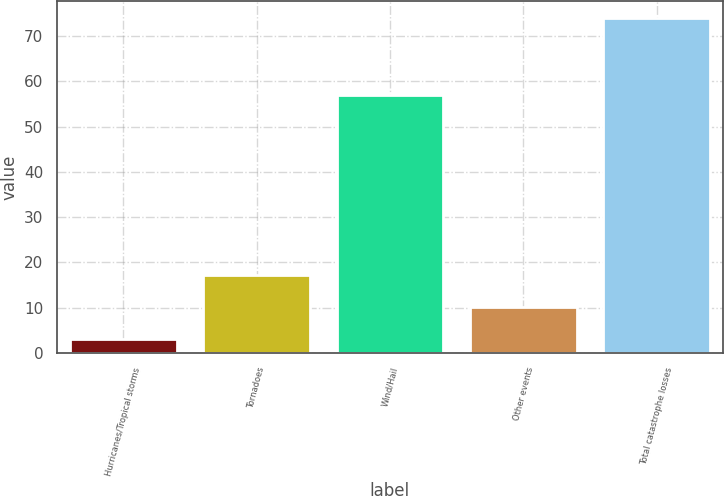<chart> <loc_0><loc_0><loc_500><loc_500><bar_chart><fcel>Hurricanes/Tropical storms<fcel>Tornadoes<fcel>Wind/Hail<fcel>Other events<fcel>Total catastrophe losses<nl><fcel>3<fcel>17.2<fcel>57<fcel>10.1<fcel>74<nl></chart> 